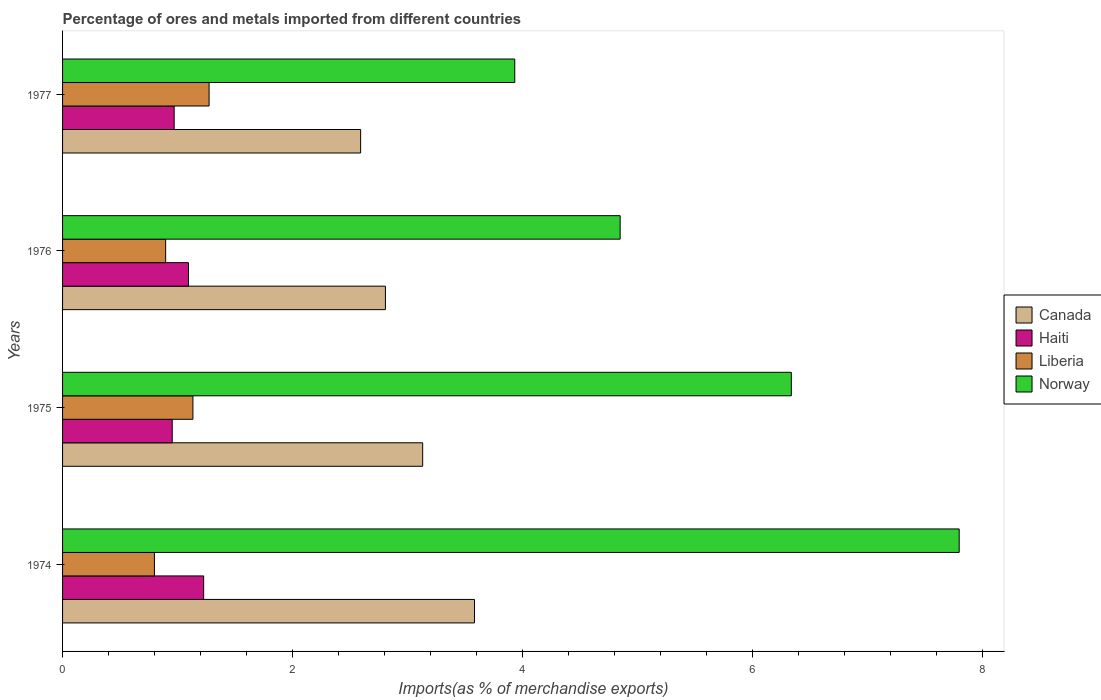How many different coloured bars are there?
Ensure brevity in your answer.  4. Are the number of bars on each tick of the Y-axis equal?
Provide a short and direct response. Yes. In how many cases, is the number of bars for a given year not equal to the number of legend labels?
Your response must be concise. 0. What is the percentage of imports to different countries in Liberia in 1974?
Your answer should be compact. 0.8. Across all years, what is the maximum percentage of imports to different countries in Canada?
Offer a terse response. 3.58. Across all years, what is the minimum percentage of imports to different countries in Canada?
Offer a very short reply. 2.59. In which year was the percentage of imports to different countries in Norway maximum?
Keep it short and to the point. 1974. In which year was the percentage of imports to different countries in Norway minimum?
Make the answer very short. 1977. What is the total percentage of imports to different countries in Canada in the graph?
Give a very brief answer. 12.11. What is the difference between the percentage of imports to different countries in Haiti in 1975 and that in 1976?
Your response must be concise. -0.14. What is the difference between the percentage of imports to different countries in Canada in 1975 and the percentage of imports to different countries in Liberia in 1974?
Your answer should be very brief. 2.33. What is the average percentage of imports to different countries in Liberia per year?
Offer a terse response. 1.03. In the year 1975, what is the difference between the percentage of imports to different countries in Haiti and percentage of imports to different countries in Canada?
Your answer should be compact. -2.18. What is the ratio of the percentage of imports to different countries in Canada in 1974 to that in 1976?
Offer a very short reply. 1.28. Is the percentage of imports to different countries in Liberia in 1975 less than that in 1976?
Ensure brevity in your answer.  No. What is the difference between the highest and the second highest percentage of imports to different countries in Norway?
Make the answer very short. 1.46. What is the difference between the highest and the lowest percentage of imports to different countries in Haiti?
Keep it short and to the point. 0.27. Is the sum of the percentage of imports to different countries in Norway in 1975 and 1976 greater than the maximum percentage of imports to different countries in Liberia across all years?
Your response must be concise. Yes. What does the 3rd bar from the top in 1975 represents?
Keep it short and to the point. Haiti. Is it the case that in every year, the sum of the percentage of imports to different countries in Canada and percentage of imports to different countries in Haiti is greater than the percentage of imports to different countries in Norway?
Your answer should be compact. No. Are all the bars in the graph horizontal?
Your answer should be compact. Yes. What is the difference between two consecutive major ticks on the X-axis?
Give a very brief answer. 2. Does the graph contain any zero values?
Provide a short and direct response. No. Does the graph contain grids?
Keep it short and to the point. No. Where does the legend appear in the graph?
Ensure brevity in your answer.  Center right. How many legend labels are there?
Keep it short and to the point. 4. How are the legend labels stacked?
Make the answer very short. Vertical. What is the title of the graph?
Provide a succinct answer. Percentage of ores and metals imported from different countries. Does "Kosovo" appear as one of the legend labels in the graph?
Your answer should be compact. No. What is the label or title of the X-axis?
Offer a very short reply. Imports(as % of merchandise exports). What is the Imports(as % of merchandise exports) of Canada in 1974?
Provide a short and direct response. 3.58. What is the Imports(as % of merchandise exports) of Haiti in 1974?
Keep it short and to the point. 1.23. What is the Imports(as % of merchandise exports) of Liberia in 1974?
Your response must be concise. 0.8. What is the Imports(as % of merchandise exports) in Norway in 1974?
Provide a short and direct response. 7.79. What is the Imports(as % of merchandise exports) in Canada in 1975?
Your answer should be very brief. 3.13. What is the Imports(as % of merchandise exports) in Haiti in 1975?
Offer a terse response. 0.95. What is the Imports(as % of merchandise exports) of Liberia in 1975?
Offer a very short reply. 1.13. What is the Imports(as % of merchandise exports) of Norway in 1975?
Your answer should be compact. 6.33. What is the Imports(as % of merchandise exports) in Canada in 1976?
Your answer should be very brief. 2.81. What is the Imports(as % of merchandise exports) in Haiti in 1976?
Offer a terse response. 1.09. What is the Imports(as % of merchandise exports) in Liberia in 1976?
Provide a succinct answer. 0.9. What is the Imports(as % of merchandise exports) in Norway in 1976?
Provide a succinct answer. 4.85. What is the Imports(as % of merchandise exports) in Canada in 1977?
Ensure brevity in your answer.  2.59. What is the Imports(as % of merchandise exports) in Haiti in 1977?
Offer a very short reply. 0.97. What is the Imports(as % of merchandise exports) of Liberia in 1977?
Offer a very short reply. 1.27. What is the Imports(as % of merchandise exports) of Norway in 1977?
Provide a short and direct response. 3.93. Across all years, what is the maximum Imports(as % of merchandise exports) in Canada?
Give a very brief answer. 3.58. Across all years, what is the maximum Imports(as % of merchandise exports) of Haiti?
Give a very brief answer. 1.23. Across all years, what is the maximum Imports(as % of merchandise exports) of Liberia?
Keep it short and to the point. 1.27. Across all years, what is the maximum Imports(as % of merchandise exports) in Norway?
Your response must be concise. 7.79. Across all years, what is the minimum Imports(as % of merchandise exports) in Canada?
Offer a very short reply. 2.59. Across all years, what is the minimum Imports(as % of merchandise exports) of Haiti?
Give a very brief answer. 0.95. Across all years, what is the minimum Imports(as % of merchandise exports) of Liberia?
Provide a succinct answer. 0.8. Across all years, what is the minimum Imports(as % of merchandise exports) of Norway?
Provide a short and direct response. 3.93. What is the total Imports(as % of merchandise exports) in Canada in the graph?
Your response must be concise. 12.11. What is the total Imports(as % of merchandise exports) of Haiti in the graph?
Make the answer very short. 4.24. What is the total Imports(as % of merchandise exports) in Liberia in the graph?
Offer a terse response. 4.1. What is the total Imports(as % of merchandise exports) in Norway in the graph?
Your answer should be compact. 22.91. What is the difference between the Imports(as % of merchandise exports) in Canada in 1974 and that in 1975?
Provide a succinct answer. 0.45. What is the difference between the Imports(as % of merchandise exports) in Haiti in 1974 and that in 1975?
Keep it short and to the point. 0.27. What is the difference between the Imports(as % of merchandise exports) in Liberia in 1974 and that in 1975?
Give a very brief answer. -0.33. What is the difference between the Imports(as % of merchandise exports) in Norway in 1974 and that in 1975?
Your answer should be very brief. 1.46. What is the difference between the Imports(as % of merchandise exports) in Canada in 1974 and that in 1976?
Give a very brief answer. 0.77. What is the difference between the Imports(as % of merchandise exports) of Haiti in 1974 and that in 1976?
Provide a short and direct response. 0.13. What is the difference between the Imports(as % of merchandise exports) of Liberia in 1974 and that in 1976?
Keep it short and to the point. -0.1. What is the difference between the Imports(as % of merchandise exports) in Norway in 1974 and that in 1976?
Provide a succinct answer. 2.95. What is the difference between the Imports(as % of merchandise exports) of Haiti in 1974 and that in 1977?
Keep it short and to the point. 0.26. What is the difference between the Imports(as % of merchandise exports) of Liberia in 1974 and that in 1977?
Make the answer very short. -0.48. What is the difference between the Imports(as % of merchandise exports) of Norway in 1974 and that in 1977?
Ensure brevity in your answer.  3.86. What is the difference between the Imports(as % of merchandise exports) in Canada in 1975 and that in 1976?
Provide a short and direct response. 0.32. What is the difference between the Imports(as % of merchandise exports) in Haiti in 1975 and that in 1976?
Your response must be concise. -0.14. What is the difference between the Imports(as % of merchandise exports) of Liberia in 1975 and that in 1976?
Provide a succinct answer. 0.24. What is the difference between the Imports(as % of merchandise exports) of Norway in 1975 and that in 1976?
Keep it short and to the point. 1.49. What is the difference between the Imports(as % of merchandise exports) of Canada in 1975 and that in 1977?
Your answer should be compact. 0.54. What is the difference between the Imports(as % of merchandise exports) of Haiti in 1975 and that in 1977?
Offer a terse response. -0.02. What is the difference between the Imports(as % of merchandise exports) of Liberia in 1975 and that in 1977?
Give a very brief answer. -0.14. What is the difference between the Imports(as % of merchandise exports) of Norway in 1975 and that in 1977?
Make the answer very short. 2.4. What is the difference between the Imports(as % of merchandise exports) in Canada in 1976 and that in 1977?
Give a very brief answer. 0.22. What is the difference between the Imports(as % of merchandise exports) in Haiti in 1976 and that in 1977?
Give a very brief answer. 0.12. What is the difference between the Imports(as % of merchandise exports) of Liberia in 1976 and that in 1977?
Your answer should be compact. -0.38. What is the difference between the Imports(as % of merchandise exports) in Norway in 1976 and that in 1977?
Your answer should be compact. 0.92. What is the difference between the Imports(as % of merchandise exports) in Canada in 1974 and the Imports(as % of merchandise exports) in Haiti in 1975?
Make the answer very short. 2.63. What is the difference between the Imports(as % of merchandise exports) in Canada in 1974 and the Imports(as % of merchandise exports) in Liberia in 1975?
Offer a very short reply. 2.45. What is the difference between the Imports(as % of merchandise exports) in Canada in 1974 and the Imports(as % of merchandise exports) in Norway in 1975?
Keep it short and to the point. -2.75. What is the difference between the Imports(as % of merchandise exports) of Haiti in 1974 and the Imports(as % of merchandise exports) of Liberia in 1975?
Make the answer very short. 0.09. What is the difference between the Imports(as % of merchandise exports) in Haiti in 1974 and the Imports(as % of merchandise exports) in Norway in 1975?
Ensure brevity in your answer.  -5.11. What is the difference between the Imports(as % of merchandise exports) in Liberia in 1974 and the Imports(as % of merchandise exports) in Norway in 1975?
Offer a terse response. -5.54. What is the difference between the Imports(as % of merchandise exports) in Canada in 1974 and the Imports(as % of merchandise exports) in Haiti in 1976?
Your answer should be very brief. 2.49. What is the difference between the Imports(as % of merchandise exports) of Canada in 1974 and the Imports(as % of merchandise exports) of Liberia in 1976?
Offer a very short reply. 2.68. What is the difference between the Imports(as % of merchandise exports) of Canada in 1974 and the Imports(as % of merchandise exports) of Norway in 1976?
Offer a terse response. -1.27. What is the difference between the Imports(as % of merchandise exports) in Haiti in 1974 and the Imports(as % of merchandise exports) in Liberia in 1976?
Provide a short and direct response. 0.33. What is the difference between the Imports(as % of merchandise exports) in Haiti in 1974 and the Imports(as % of merchandise exports) in Norway in 1976?
Provide a succinct answer. -3.62. What is the difference between the Imports(as % of merchandise exports) in Liberia in 1974 and the Imports(as % of merchandise exports) in Norway in 1976?
Your answer should be compact. -4.05. What is the difference between the Imports(as % of merchandise exports) in Canada in 1974 and the Imports(as % of merchandise exports) in Haiti in 1977?
Your response must be concise. 2.61. What is the difference between the Imports(as % of merchandise exports) in Canada in 1974 and the Imports(as % of merchandise exports) in Liberia in 1977?
Your response must be concise. 2.31. What is the difference between the Imports(as % of merchandise exports) in Canada in 1974 and the Imports(as % of merchandise exports) in Norway in 1977?
Provide a succinct answer. -0.35. What is the difference between the Imports(as % of merchandise exports) of Haiti in 1974 and the Imports(as % of merchandise exports) of Liberia in 1977?
Offer a terse response. -0.05. What is the difference between the Imports(as % of merchandise exports) in Haiti in 1974 and the Imports(as % of merchandise exports) in Norway in 1977?
Give a very brief answer. -2.7. What is the difference between the Imports(as % of merchandise exports) of Liberia in 1974 and the Imports(as % of merchandise exports) of Norway in 1977?
Provide a short and direct response. -3.13. What is the difference between the Imports(as % of merchandise exports) of Canada in 1975 and the Imports(as % of merchandise exports) of Haiti in 1976?
Ensure brevity in your answer.  2.04. What is the difference between the Imports(as % of merchandise exports) in Canada in 1975 and the Imports(as % of merchandise exports) in Liberia in 1976?
Offer a very short reply. 2.23. What is the difference between the Imports(as % of merchandise exports) of Canada in 1975 and the Imports(as % of merchandise exports) of Norway in 1976?
Give a very brief answer. -1.72. What is the difference between the Imports(as % of merchandise exports) in Haiti in 1975 and the Imports(as % of merchandise exports) in Liberia in 1976?
Ensure brevity in your answer.  0.06. What is the difference between the Imports(as % of merchandise exports) of Haiti in 1975 and the Imports(as % of merchandise exports) of Norway in 1976?
Keep it short and to the point. -3.89. What is the difference between the Imports(as % of merchandise exports) in Liberia in 1975 and the Imports(as % of merchandise exports) in Norway in 1976?
Provide a succinct answer. -3.71. What is the difference between the Imports(as % of merchandise exports) of Canada in 1975 and the Imports(as % of merchandise exports) of Haiti in 1977?
Provide a short and direct response. 2.16. What is the difference between the Imports(as % of merchandise exports) in Canada in 1975 and the Imports(as % of merchandise exports) in Liberia in 1977?
Your answer should be very brief. 1.86. What is the difference between the Imports(as % of merchandise exports) in Canada in 1975 and the Imports(as % of merchandise exports) in Norway in 1977?
Provide a succinct answer. -0.8. What is the difference between the Imports(as % of merchandise exports) of Haiti in 1975 and the Imports(as % of merchandise exports) of Liberia in 1977?
Your answer should be very brief. -0.32. What is the difference between the Imports(as % of merchandise exports) of Haiti in 1975 and the Imports(as % of merchandise exports) of Norway in 1977?
Your response must be concise. -2.98. What is the difference between the Imports(as % of merchandise exports) in Liberia in 1975 and the Imports(as % of merchandise exports) in Norway in 1977?
Your answer should be very brief. -2.8. What is the difference between the Imports(as % of merchandise exports) in Canada in 1976 and the Imports(as % of merchandise exports) in Haiti in 1977?
Give a very brief answer. 1.84. What is the difference between the Imports(as % of merchandise exports) in Canada in 1976 and the Imports(as % of merchandise exports) in Liberia in 1977?
Your response must be concise. 1.53. What is the difference between the Imports(as % of merchandise exports) of Canada in 1976 and the Imports(as % of merchandise exports) of Norway in 1977?
Your answer should be compact. -1.12. What is the difference between the Imports(as % of merchandise exports) in Haiti in 1976 and the Imports(as % of merchandise exports) in Liberia in 1977?
Ensure brevity in your answer.  -0.18. What is the difference between the Imports(as % of merchandise exports) of Haiti in 1976 and the Imports(as % of merchandise exports) of Norway in 1977?
Provide a succinct answer. -2.84. What is the difference between the Imports(as % of merchandise exports) of Liberia in 1976 and the Imports(as % of merchandise exports) of Norway in 1977?
Your answer should be compact. -3.03. What is the average Imports(as % of merchandise exports) in Canada per year?
Provide a short and direct response. 3.03. What is the average Imports(as % of merchandise exports) of Haiti per year?
Keep it short and to the point. 1.06. What is the average Imports(as % of merchandise exports) of Liberia per year?
Offer a very short reply. 1.03. What is the average Imports(as % of merchandise exports) of Norway per year?
Your response must be concise. 5.73. In the year 1974, what is the difference between the Imports(as % of merchandise exports) of Canada and Imports(as % of merchandise exports) of Haiti?
Provide a succinct answer. 2.35. In the year 1974, what is the difference between the Imports(as % of merchandise exports) of Canada and Imports(as % of merchandise exports) of Liberia?
Make the answer very short. 2.78. In the year 1974, what is the difference between the Imports(as % of merchandise exports) in Canada and Imports(as % of merchandise exports) in Norway?
Give a very brief answer. -4.21. In the year 1974, what is the difference between the Imports(as % of merchandise exports) in Haiti and Imports(as % of merchandise exports) in Liberia?
Offer a very short reply. 0.43. In the year 1974, what is the difference between the Imports(as % of merchandise exports) of Haiti and Imports(as % of merchandise exports) of Norway?
Offer a very short reply. -6.57. In the year 1974, what is the difference between the Imports(as % of merchandise exports) of Liberia and Imports(as % of merchandise exports) of Norway?
Your response must be concise. -7. In the year 1975, what is the difference between the Imports(as % of merchandise exports) of Canada and Imports(as % of merchandise exports) of Haiti?
Keep it short and to the point. 2.18. In the year 1975, what is the difference between the Imports(as % of merchandise exports) of Canada and Imports(as % of merchandise exports) of Liberia?
Keep it short and to the point. 2. In the year 1975, what is the difference between the Imports(as % of merchandise exports) in Canada and Imports(as % of merchandise exports) in Norway?
Your answer should be very brief. -3.2. In the year 1975, what is the difference between the Imports(as % of merchandise exports) in Haiti and Imports(as % of merchandise exports) in Liberia?
Ensure brevity in your answer.  -0.18. In the year 1975, what is the difference between the Imports(as % of merchandise exports) of Haiti and Imports(as % of merchandise exports) of Norway?
Your response must be concise. -5.38. In the year 1975, what is the difference between the Imports(as % of merchandise exports) in Liberia and Imports(as % of merchandise exports) in Norway?
Offer a terse response. -5.2. In the year 1976, what is the difference between the Imports(as % of merchandise exports) of Canada and Imports(as % of merchandise exports) of Haiti?
Your response must be concise. 1.71. In the year 1976, what is the difference between the Imports(as % of merchandise exports) of Canada and Imports(as % of merchandise exports) of Liberia?
Offer a very short reply. 1.91. In the year 1976, what is the difference between the Imports(as % of merchandise exports) of Canada and Imports(as % of merchandise exports) of Norway?
Your answer should be compact. -2.04. In the year 1976, what is the difference between the Imports(as % of merchandise exports) of Haiti and Imports(as % of merchandise exports) of Liberia?
Keep it short and to the point. 0.2. In the year 1976, what is the difference between the Imports(as % of merchandise exports) in Haiti and Imports(as % of merchandise exports) in Norway?
Your answer should be compact. -3.75. In the year 1976, what is the difference between the Imports(as % of merchandise exports) of Liberia and Imports(as % of merchandise exports) of Norway?
Ensure brevity in your answer.  -3.95. In the year 1977, what is the difference between the Imports(as % of merchandise exports) of Canada and Imports(as % of merchandise exports) of Haiti?
Offer a very short reply. 1.62. In the year 1977, what is the difference between the Imports(as % of merchandise exports) in Canada and Imports(as % of merchandise exports) in Liberia?
Your answer should be compact. 1.32. In the year 1977, what is the difference between the Imports(as % of merchandise exports) of Canada and Imports(as % of merchandise exports) of Norway?
Offer a terse response. -1.34. In the year 1977, what is the difference between the Imports(as % of merchandise exports) in Haiti and Imports(as % of merchandise exports) in Liberia?
Offer a very short reply. -0.3. In the year 1977, what is the difference between the Imports(as % of merchandise exports) of Haiti and Imports(as % of merchandise exports) of Norway?
Your answer should be compact. -2.96. In the year 1977, what is the difference between the Imports(as % of merchandise exports) in Liberia and Imports(as % of merchandise exports) in Norway?
Make the answer very short. -2.66. What is the ratio of the Imports(as % of merchandise exports) of Canada in 1974 to that in 1975?
Your answer should be compact. 1.14. What is the ratio of the Imports(as % of merchandise exports) in Haiti in 1974 to that in 1975?
Offer a very short reply. 1.29. What is the ratio of the Imports(as % of merchandise exports) of Liberia in 1974 to that in 1975?
Your response must be concise. 0.7. What is the ratio of the Imports(as % of merchandise exports) of Norway in 1974 to that in 1975?
Keep it short and to the point. 1.23. What is the ratio of the Imports(as % of merchandise exports) of Canada in 1974 to that in 1976?
Your response must be concise. 1.28. What is the ratio of the Imports(as % of merchandise exports) in Haiti in 1974 to that in 1976?
Your answer should be very brief. 1.12. What is the ratio of the Imports(as % of merchandise exports) of Liberia in 1974 to that in 1976?
Your response must be concise. 0.89. What is the ratio of the Imports(as % of merchandise exports) in Norway in 1974 to that in 1976?
Your answer should be very brief. 1.61. What is the ratio of the Imports(as % of merchandise exports) in Canada in 1974 to that in 1977?
Offer a terse response. 1.38. What is the ratio of the Imports(as % of merchandise exports) in Haiti in 1974 to that in 1977?
Give a very brief answer. 1.26. What is the ratio of the Imports(as % of merchandise exports) in Liberia in 1974 to that in 1977?
Your answer should be compact. 0.63. What is the ratio of the Imports(as % of merchandise exports) of Norway in 1974 to that in 1977?
Provide a short and direct response. 1.98. What is the ratio of the Imports(as % of merchandise exports) of Canada in 1975 to that in 1976?
Your answer should be compact. 1.12. What is the ratio of the Imports(as % of merchandise exports) in Haiti in 1975 to that in 1976?
Give a very brief answer. 0.87. What is the ratio of the Imports(as % of merchandise exports) in Liberia in 1975 to that in 1976?
Your response must be concise. 1.26. What is the ratio of the Imports(as % of merchandise exports) of Norway in 1975 to that in 1976?
Give a very brief answer. 1.31. What is the ratio of the Imports(as % of merchandise exports) of Canada in 1975 to that in 1977?
Offer a very short reply. 1.21. What is the ratio of the Imports(as % of merchandise exports) of Haiti in 1975 to that in 1977?
Your response must be concise. 0.98. What is the ratio of the Imports(as % of merchandise exports) of Liberia in 1975 to that in 1977?
Ensure brevity in your answer.  0.89. What is the ratio of the Imports(as % of merchandise exports) in Norway in 1975 to that in 1977?
Your response must be concise. 1.61. What is the ratio of the Imports(as % of merchandise exports) of Canada in 1976 to that in 1977?
Your response must be concise. 1.08. What is the ratio of the Imports(as % of merchandise exports) of Haiti in 1976 to that in 1977?
Ensure brevity in your answer.  1.13. What is the ratio of the Imports(as % of merchandise exports) in Liberia in 1976 to that in 1977?
Offer a very short reply. 0.7. What is the ratio of the Imports(as % of merchandise exports) of Norway in 1976 to that in 1977?
Ensure brevity in your answer.  1.23. What is the difference between the highest and the second highest Imports(as % of merchandise exports) of Canada?
Your answer should be very brief. 0.45. What is the difference between the highest and the second highest Imports(as % of merchandise exports) of Haiti?
Your answer should be compact. 0.13. What is the difference between the highest and the second highest Imports(as % of merchandise exports) in Liberia?
Offer a terse response. 0.14. What is the difference between the highest and the second highest Imports(as % of merchandise exports) in Norway?
Your response must be concise. 1.46. What is the difference between the highest and the lowest Imports(as % of merchandise exports) of Canada?
Offer a very short reply. 0.99. What is the difference between the highest and the lowest Imports(as % of merchandise exports) in Haiti?
Offer a terse response. 0.27. What is the difference between the highest and the lowest Imports(as % of merchandise exports) of Liberia?
Provide a succinct answer. 0.48. What is the difference between the highest and the lowest Imports(as % of merchandise exports) in Norway?
Your response must be concise. 3.86. 